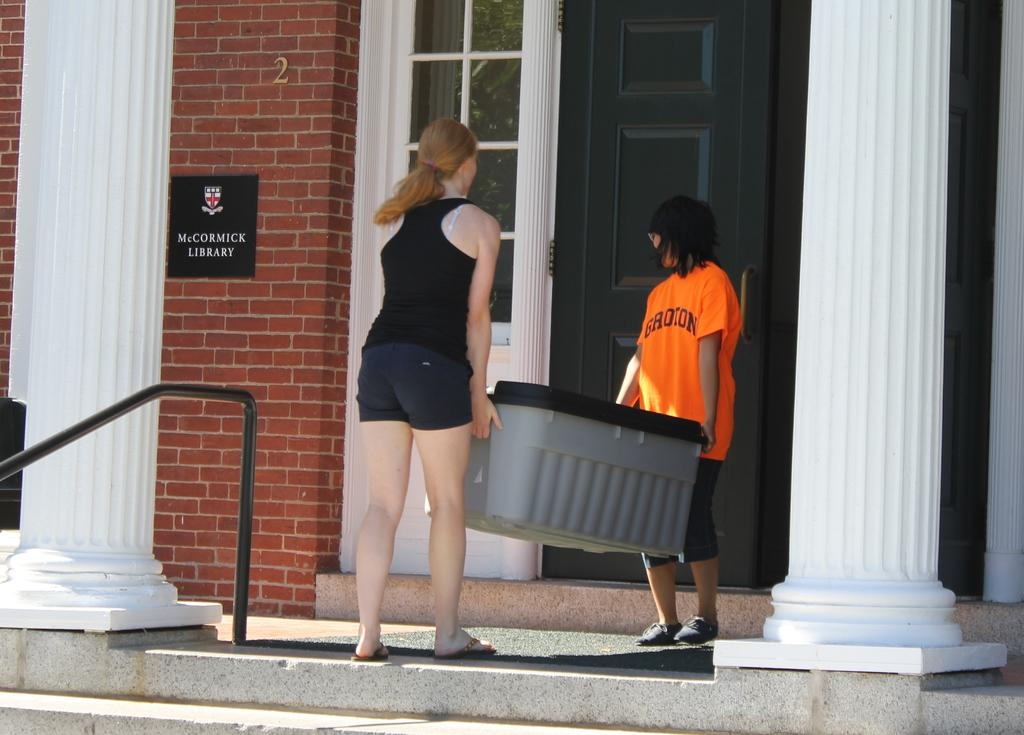How many people are in the image? There are two ladies in the image. What are the ladies holding in their hands? The ladies are holding a box in their hands. What architectural features can be seen on either side of the ladies? There are two white pillars on either side of the ladies. What can be seen in the background of the image? There is a door and a wall in the background of the image. What type of loaf can be seen on the wall in the image? There is no loaf present on the wall in the image. Can you tell me how the mist is affecting the visibility of the ladies in the image? There is no mist present in the image; the ladies and their surroundings are clearly visible. 